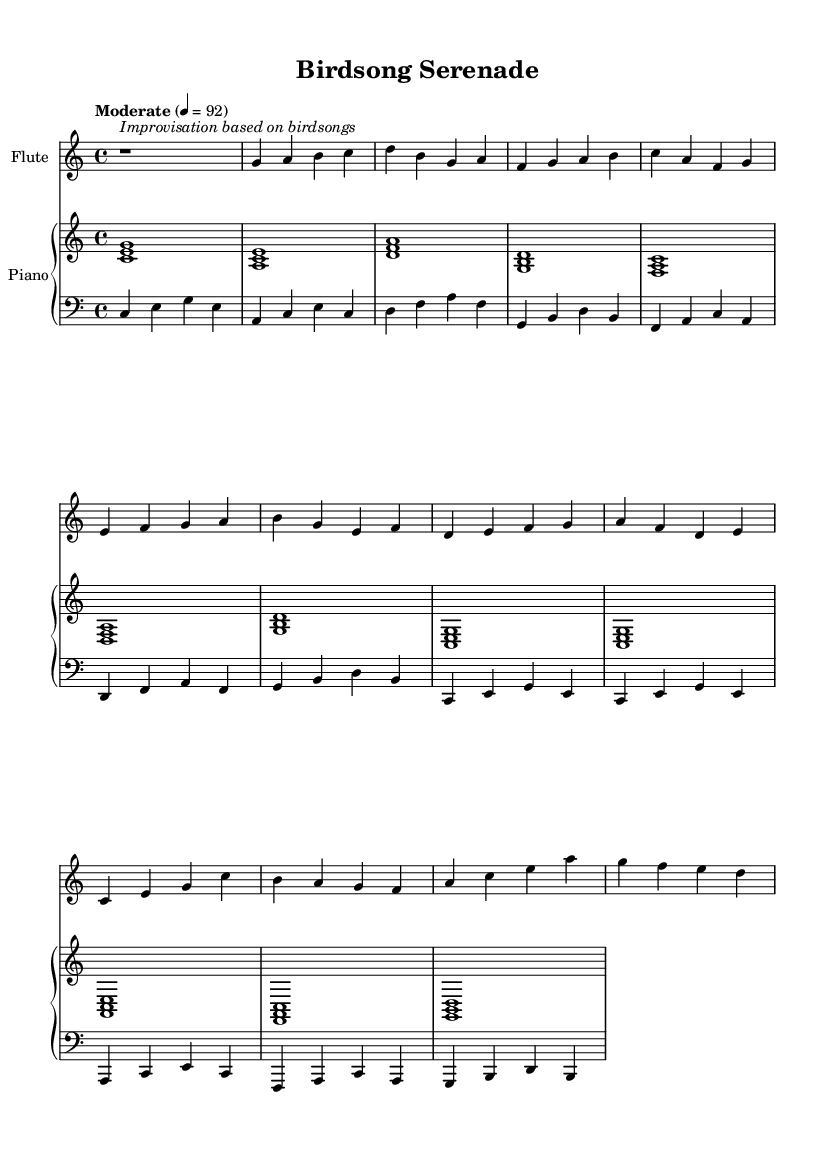What is the key signature of this music? The key signature is C major, which has no sharps or flats indicated at the beginning of the staff.
Answer: C major What is the time signature of this music? The time signature is 4/4, which is indicated at the beginning of the score. It shows that there are four beats in each measure.
Answer: 4/4 What is the tempo marking? The tempo marking indicates "Moderate" with a metronome speed of 92 beats per minute, showing how fast the piece should be played.
Answer: Moderate 4 = 92 How many measures are in the flute part? By counting the measures in the flute part, there are 12 measures as indicated by the bar lines.
Answer: 12 What instrument plays the harmony? The harmony is provided by the piano, which plays chords beneath the flute melody throughout the piece.
Answer: Piano How does the flute part relate to birdsongs? The flute part includes an improvisation section and utilizes a variety of melodic contours that mimic the diverse sounds and rhythms of birdsongs.
Answer: Improvisation based on birdsongs What is the clef used for the bass part? The bass part uses a bass clef, which indicates the lower range of notes that the bass instrument will play.
Answer: Bass clef 